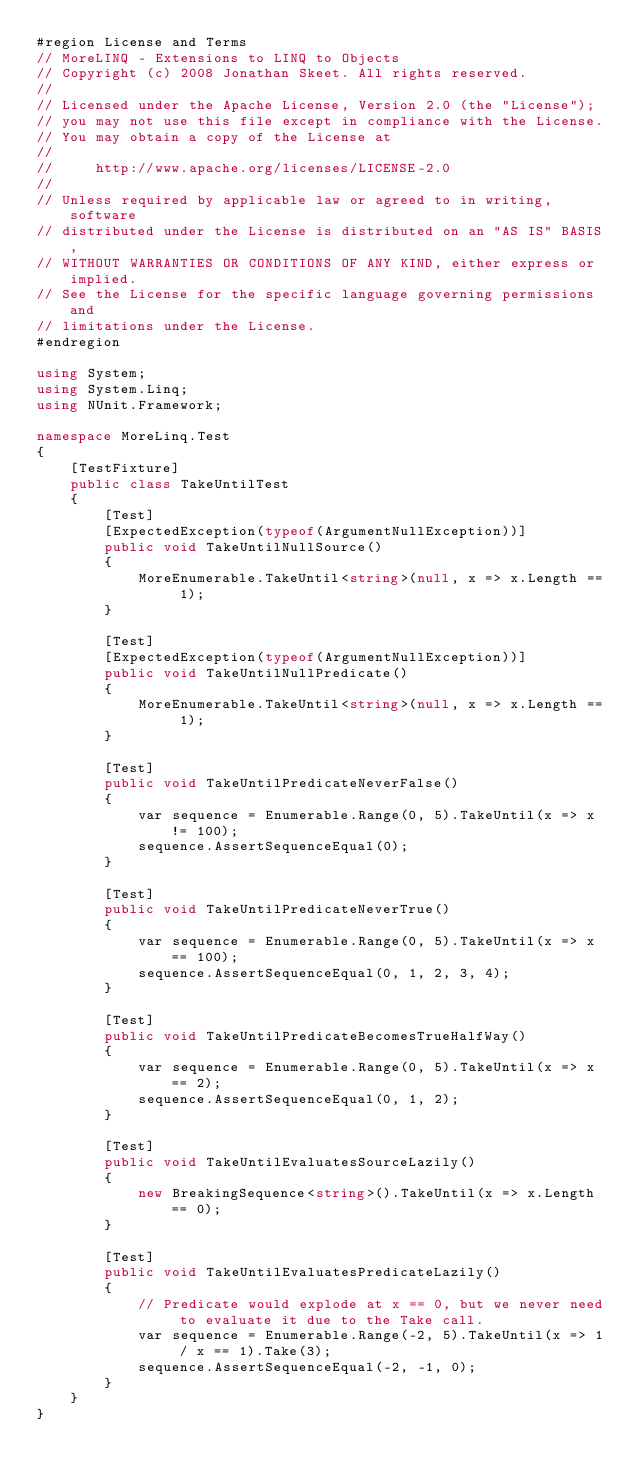Convert code to text. <code><loc_0><loc_0><loc_500><loc_500><_C#_>#region License and Terms
// MoreLINQ - Extensions to LINQ to Objects
// Copyright (c) 2008 Jonathan Skeet. All rights reserved.
// 
// Licensed under the Apache License, Version 2.0 (the "License");
// you may not use this file except in compliance with the License.
// You may obtain a copy of the License at
// 
//     http://www.apache.org/licenses/LICENSE-2.0
// 
// Unless required by applicable law or agreed to in writing, software
// distributed under the License is distributed on an "AS IS" BASIS,
// WITHOUT WARRANTIES OR CONDITIONS OF ANY KIND, either express or implied.
// See the License for the specific language governing permissions and
// limitations under the License.
#endregion

using System;
using System.Linq;
using NUnit.Framework;

namespace MoreLinq.Test
{
    [TestFixture]
    public class TakeUntilTest
    {
        [Test]
        [ExpectedException(typeof(ArgumentNullException))]
        public void TakeUntilNullSource()
        {
            MoreEnumerable.TakeUntil<string>(null, x => x.Length == 1);
        }

        [Test]
        [ExpectedException(typeof(ArgumentNullException))]
        public void TakeUntilNullPredicate()
        {
            MoreEnumerable.TakeUntil<string>(null, x => x.Length == 1);
        }

        [Test]
        public void TakeUntilPredicateNeverFalse()
        {
            var sequence = Enumerable.Range(0, 5).TakeUntil(x => x != 100);
            sequence.AssertSequenceEqual(0);
        }

        [Test]
        public void TakeUntilPredicateNeverTrue()
        {
            var sequence = Enumerable.Range(0, 5).TakeUntil(x => x == 100);
            sequence.AssertSequenceEqual(0, 1, 2, 3, 4);
        }

        [Test]
        public void TakeUntilPredicateBecomesTrueHalfWay()
        {
            var sequence = Enumerable.Range(0, 5).TakeUntil(x => x == 2);
            sequence.AssertSequenceEqual(0, 1, 2);
        }

        [Test]
        public void TakeUntilEvaluatesSourceLazily()
        {
            new BreakingSequence<string>().TakeUntil(x => x.Length == 0);
        }

        [Test]
        public void TakeUntilEvaluatesPredicateLazily()
        {
            // Predicate would explode at x == 0, but we never need to evaluate it due to the Take call.
            var sequence = Enumerable.Range(-2, 5).TakeUntil(x => 1 / x == 1).Take(3);
            sequence.AssertSequenceEqual(-2, -1, 0);
        }
    }
}
</code> 